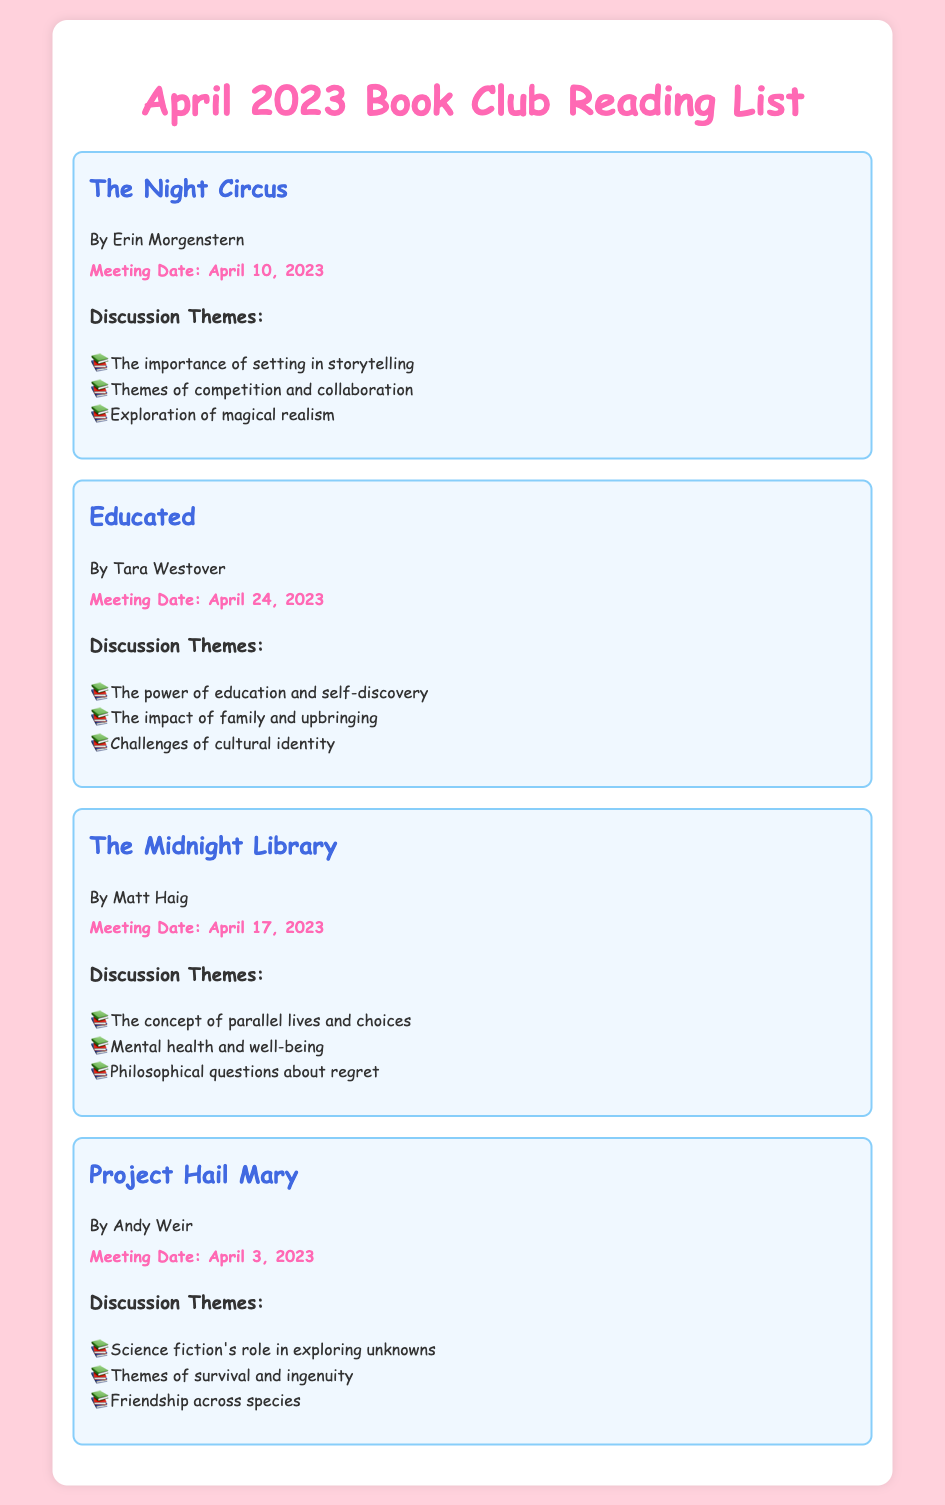What is the title of the book discussed on April 10, 2023? The book listed for April 10, 2023, is "The Night Circus."
Answer: The Night Circus Who is the author of "Educated"? "Educated" is written by Tara Westover.
Answer: Tara Westover What is the date for the meeting discussing "The Midnight Library"? The meeting for "The Midnight Library" is scheduled for April 17, 2023.
Answer: April 17, 2023 List one theme discussed in "Project Hail Mary." One theme from "Project Hail Mary" is "Science fiction's role in exploring unknowns."
Answer: Science fiction's role in exploring unknowns How many books are included in the reading list for April 2023? There are four books listed in the document.
Answer: Four 